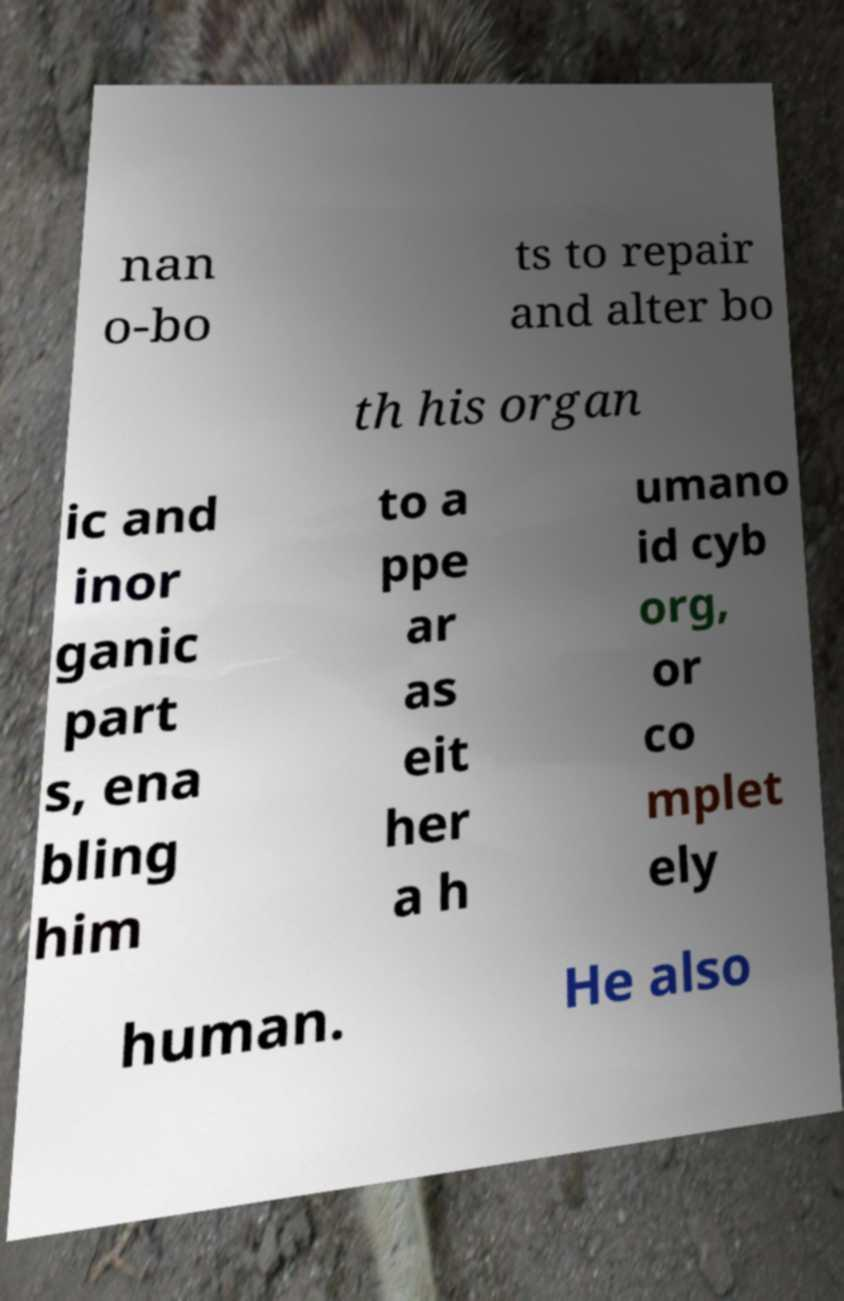Please identify and transcribe the text found in this image. nan o-bo ts to repair and alter bo th his organ ic and inor ganic part s, ena bling him to a ppe ar as eit her a h umano id cyb org, or co mplet ely human. He also 